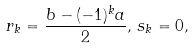Convert formula to latex. <formula><loc_0><loc_0><loc_500><loc_500>r _ { k } = \frac { b - ( - 1 ) ^ { k } a } { 2 } , \, s _ { k } = 0 ,</formula> 